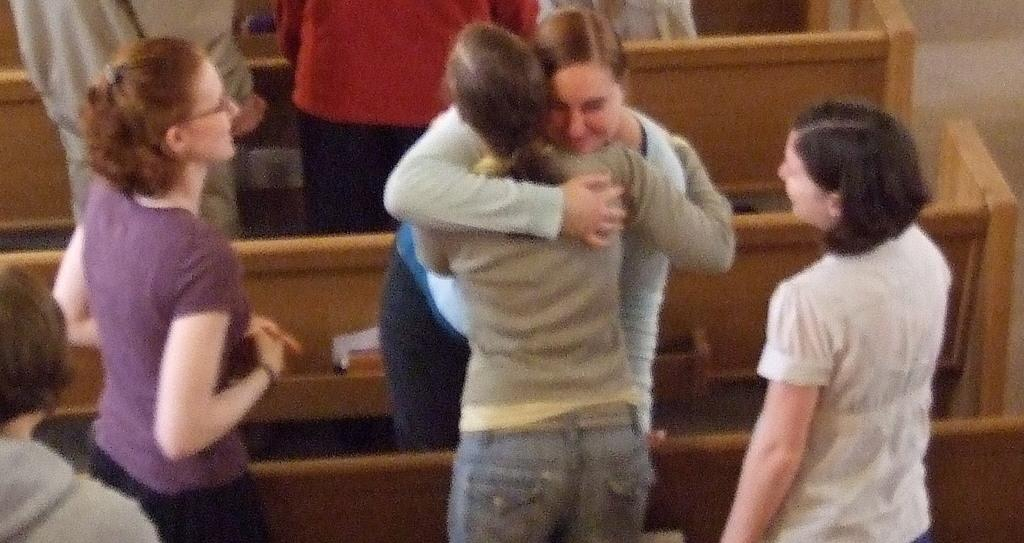What is happening in the image involving the group of people? Two women are hugging in the image. Can you describe any objects made of wood in the image? There are wooden objects in the image. What color is the silver volleyball in the image? There is no silver volleyball present in the image. What type of container is being used to carry water in the image? There is no container or water present in the image. 